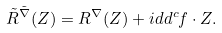Convert formula to latex. <formula><loc_0><loc_0><loc_500><loc_500>\tilde { R } ^ { \tilde { \nabla } } ( Z ) = R ^ { \nabla } ( Z ) + i d d ^ { c } f \cdot Z .</formula> 